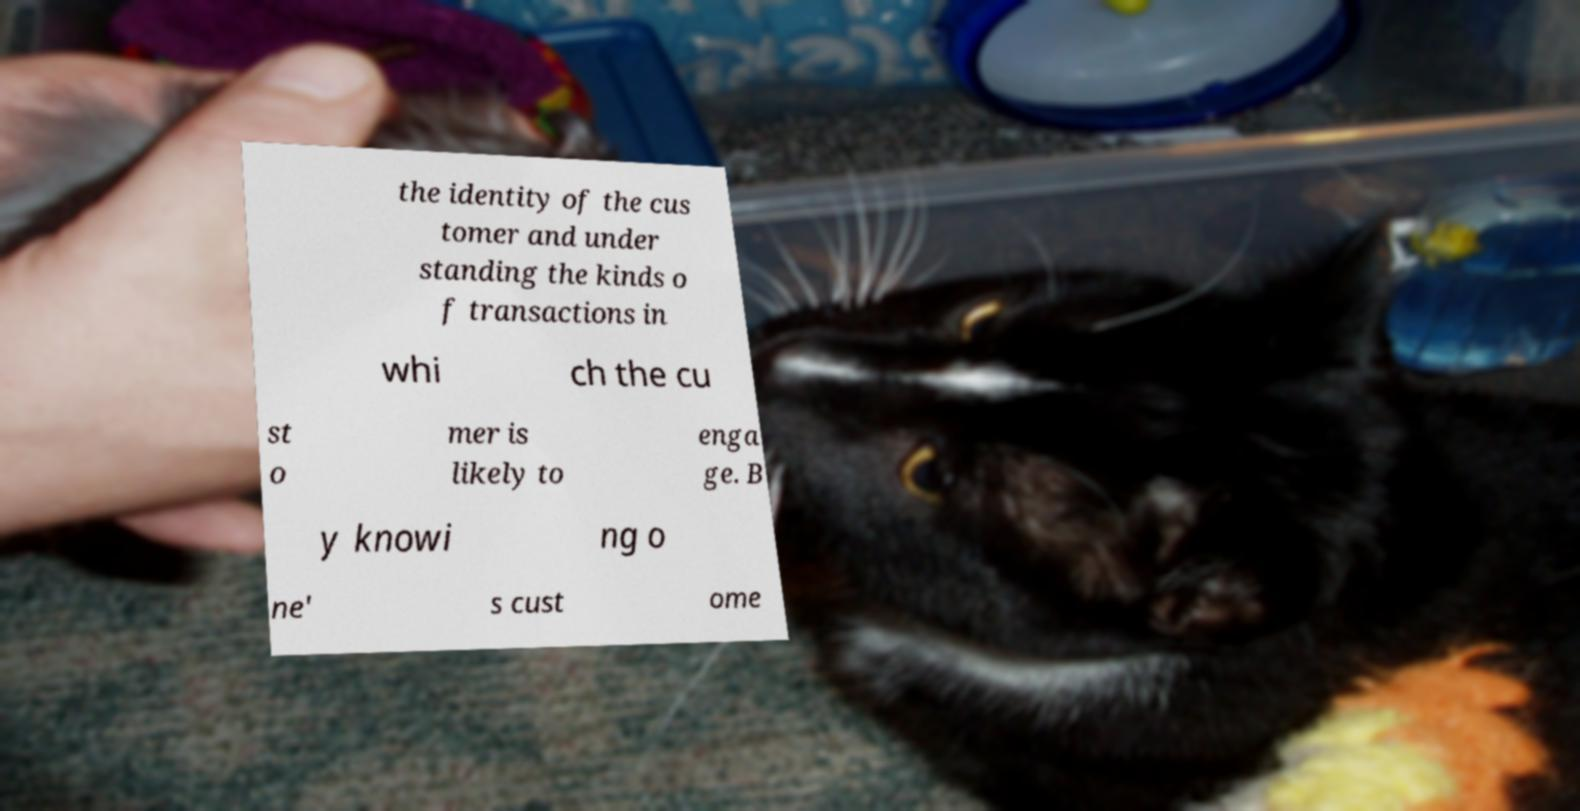What messages or text are displayed in this image? I need them in a readable, typed format. the identity of the cus tomer and under standing the kinds o f transactions in whi ch the cu st o mer is likely to enga ge. B y knowi ng o ne' s cust ome 